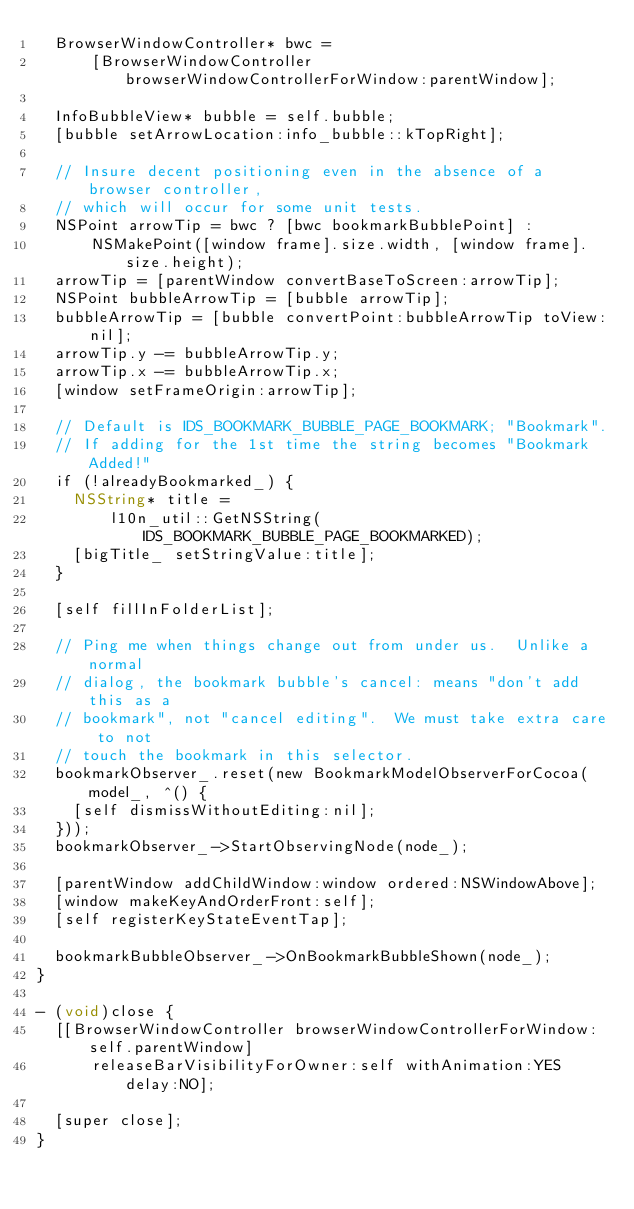<code> <loc_0><loc_0><loc_500><loc_500><_ObjectiveC_>  BrowserWindowController* bwc =
      [BrowserWindowController browserWindowControllerForWindow:parentWindow];

  InfoBubbleView* bubble = self.bubble;
  [bubble setArrowLocation:info_bubble::kTopRight];

  // Insure decent positioning even in the absence of a browser controller,
  // which will occur for some unit tests.
  NSPoint arrowTip = bwc ? [bwc bookmarkBubblePoint] :
      NSMakePoint([window frame].size.width, [window frame].size.height);
  arrowTip = [parentWindow convertBaseToScreen:arrowTip];
  NSPoint bubbleArrowTip = [bubble arrowTip];
  bubbleArrowTip = [bubble convertPoint:bubbleArrowTip toView:nil];
  arrowTip.y -= bubbleArrowTip.y;
  arrowTip.x -= bubbleArrowTip.x;
  [window setFrameOrigin:arrowTip];

  // Default is IDS_BOOKMARK_BUBBLE_PAGE_BOOKMARK; "Bookmark".
  // If adding for the 1st time the string becomes "Bookmark Added!"
  if (!alreadyBookmarked_) {
    NSString* title =
        l10n_util::GetNSString(IDS_BOOKMARK_BUBBLE_PAGE_BOOKMARKED);
    [bigTitle_ setStringValue:title];
  }

  [self fillInFolderList];

  // Ping me when things change out from under us.  Unlike a normal
  // dialog, the bookmark bubble's cancel: means "don't add this as a
  // bookmark", not "cancel editing".  We must take extra care to not
  // touch the bookmark in this selector.
  bookmarkObserver_.reset(new BookmarkModelObserverForCocoa(model_, ^() {
    [self dismissWithoutEditing:nil];
  }));
  bookmarkObserver_->StartObservingNode(node_);

  [parentWindow addChildWindow:window ordered:NSWindowAbove];
  [window makeKeyAndOrderFront:self];
  [self registerKeyStateEventTap];

  bookmarkBubbleObserver_->OnBookmarkBubbleShown(node_);
}

- (void)close {
  [[BrowserWindowController browserWindowControllerForWindow:self.parentWindow]
      releaseBarVisibilityForOwner:self withAnimation:YES delay:NO];

  [super close];
}
</code> 